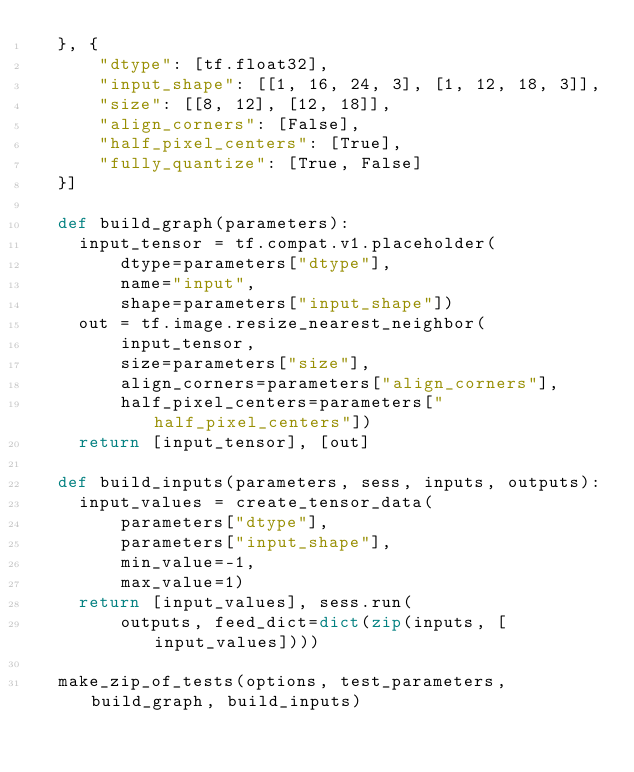<code> <loc_0><loc_0><loc_500><loc_500><_Python_>  }, {
      "dtype": [tf.float32],
      "input_shape": [[1, 16, 24, 3], [1, 12, 18, 3]],
      "size": [[8, 12], [12, 18]],
      "align_corners": [False],
      "half_pixel_centers": [True],
      "fully_quantize": [True, False]
  }]

  def build_graph(parameters):
    input_tensor = tf.compat.v1.placeholder(
        dtype=parameters["dtype"],
        name="input",
        shape=parameters["input_shape"])
    out = tf.image.resize_nearest_neighbor(
        input_tensor,
        size=parameters["size"],
        align_corners=parameters["align_corners"],
        half_pixel_centers=parameters["half_pixel_centers"])
    return [input_tensor], [out]

  def build_inputs(parameters, sess, inputs, outputs):
    input_values = create_tensor_data(
        parameters["dtype"],
        parameters["input_shape"],
        min_value=-1,
        max_value=1)
    return [input_values], sess.run(
        outputs, feed_dict=dict(zip(inputs, [input_values])))

  make_zip_of_tests(options, test_parameters, build_graph, build_inputs)
</code> 